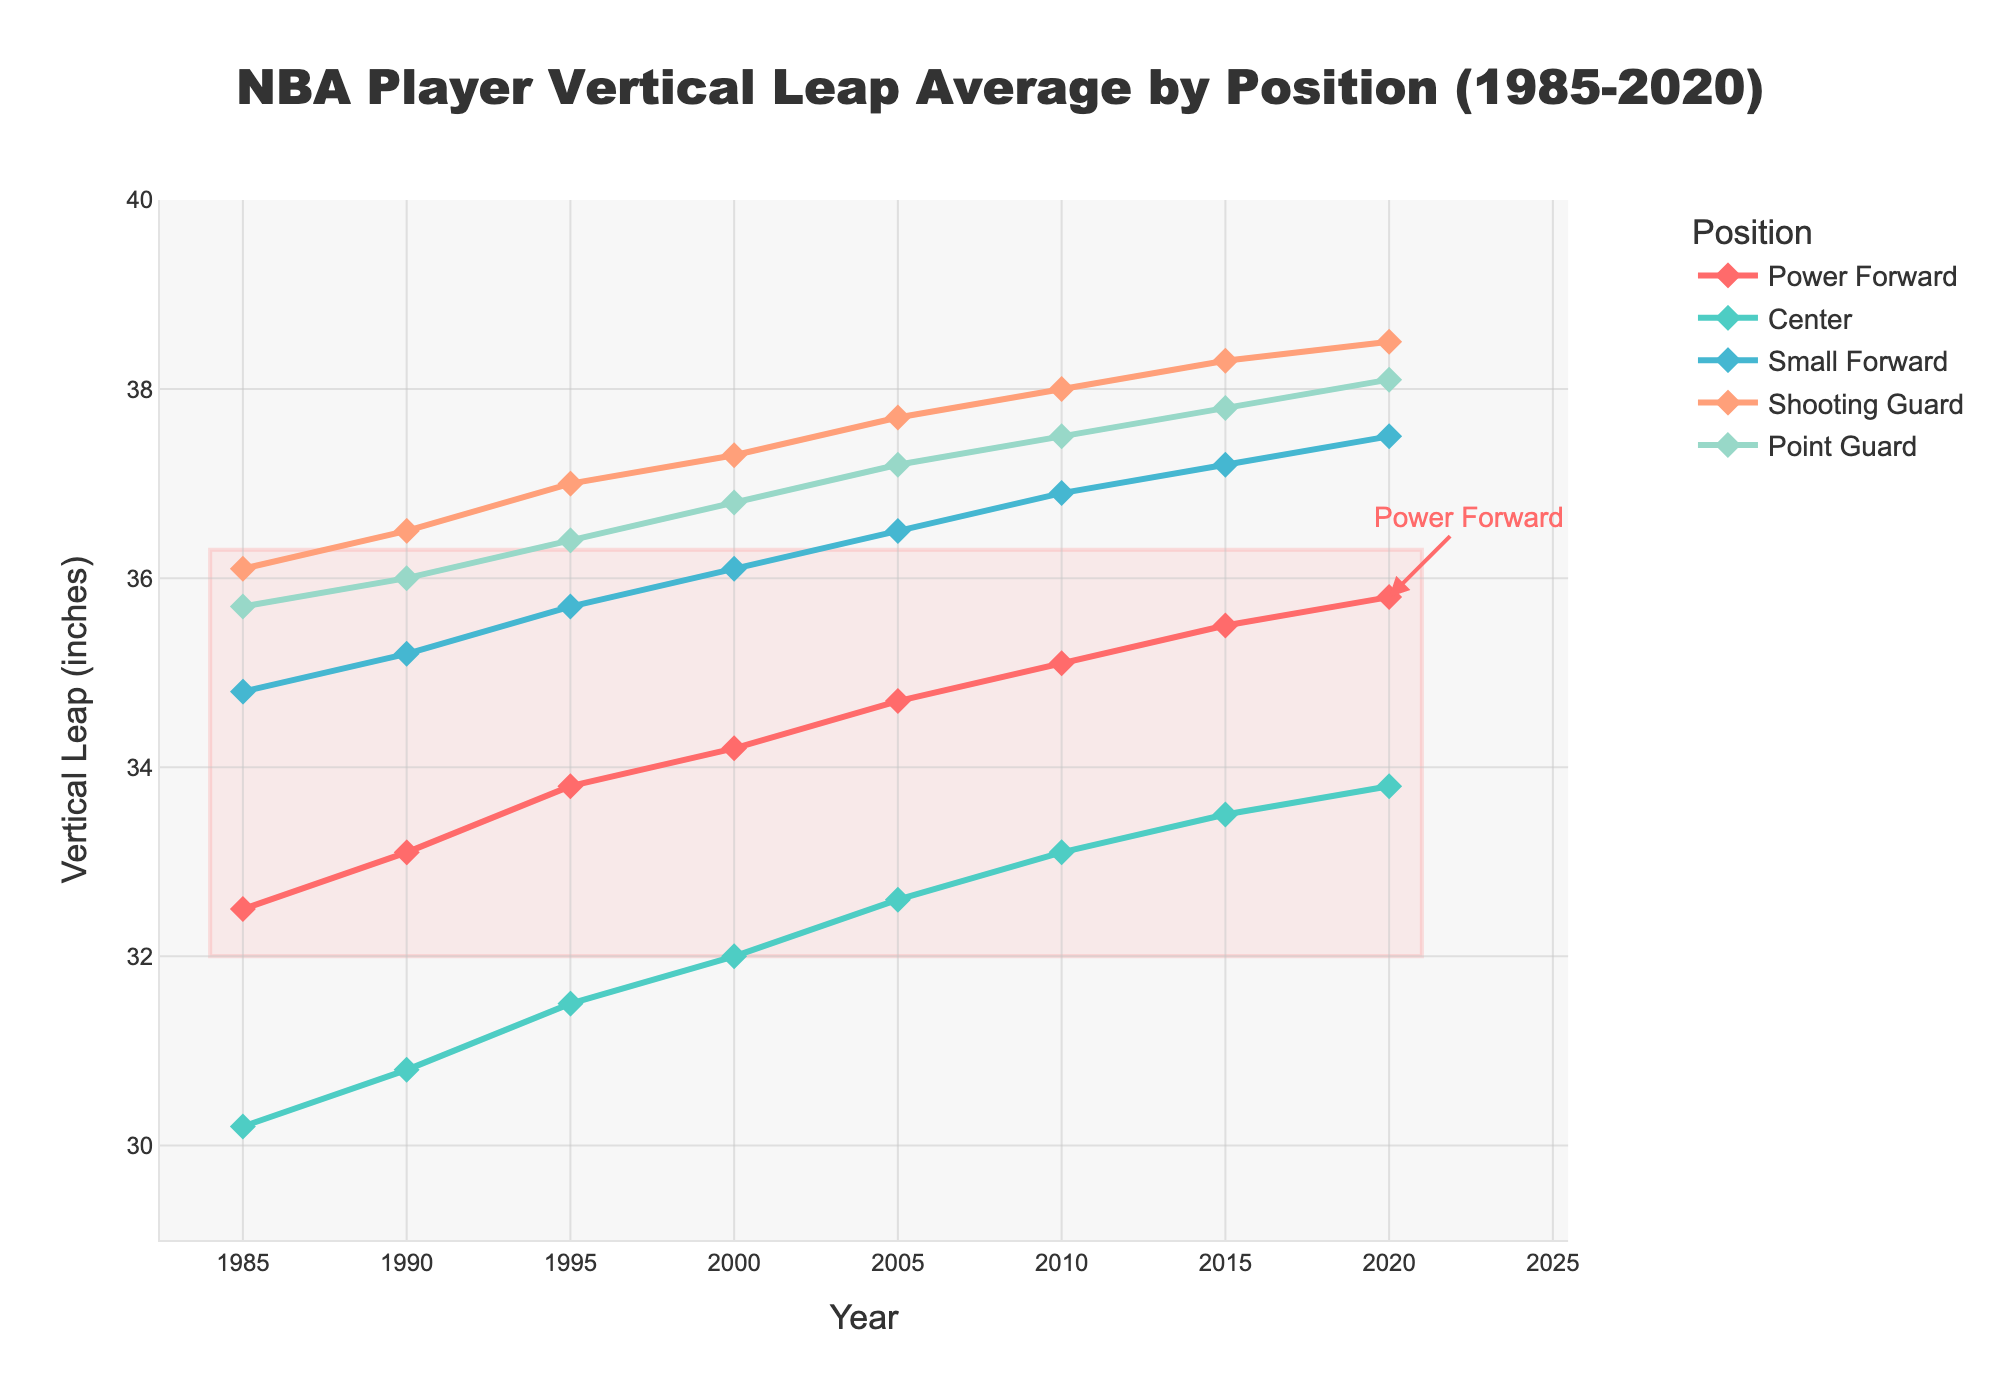What's the trend in vertical leap for Power Forwards from 1985 to 2020? The vertical leap for Power Forwards shows a gradual increase from 32.5 inches in 1985 to 35.8 inches in 2020. Each data point has a slightly higher value than the previous year, indicating an upward trend.
Answer: Gradual increase Which position had the highest vertical leap in 2010? By comparing the values for each position in 2010, the Shooting Guard had the highest vertical leap at 38.0 inches.
Answer: Shooting Guard How does the vertical leap of Centers in 2000 compare to that of Point Guards in 2000? In 2000, the vertical leap for Centers was 32.0 inches, while for Point Guards it was 36.8 inches. Comparing these, Point Guards had a significantly higher vertical leap than Centers.
Answer: Point Guards had a higher vertical leap What is the difference in vertical leap between Small Forwards and Power Forwards in 2020? The vertical leap for Small Forwards in 2020 was 37.5 inches and for Power Forwards it was 35.8 inches. The difference is 37.5 - 35.8 = 1.7 inches.
Answer: 1.7 inches Which two positions had the closest vertical leap values in 1995? In 1995, the values are: Power Forward (33.8), Center (31.5), Small Forward (35.7), Shooting Guard (37.0), and Point Guard (36.4). The closest values are for Shooting Guard (37.0) and Point Guard (36.4) with a difference of 0.6 inches.
Answer: Shooting Guard and Point Guard What is the average vertical leap for all positions in 2015? The vertical leaps for each position in 2015 are: Power Forward (35.5), Center (33.5), Small Forward (37.2), Shooting Guard (38.3), and Point Guard (37.8). The sum is 35.5 + 33.5 + 37.2 + 38.3 + 37.8 = 182.3. The average is 182.3 / 5 = 36.46 inches.
Answer: 36.46 inches Which position experienced the largest increase in vertical leap from 1985 to 2020? By calculating the increase for each position: Power Forward (3.3 inches), Center (3.6 inches), Small Forward (2.7 inches), Shooting Guard (2.4 inches), and Point Guard (2.4 inches). The Center position experienced the largest increase from 30.2 to 33.8 inches, a 3.6-inch increase.
Answer: Center How did the vertical leap of Shooting Guards compare to that of Small Forwards over the years? Over the entire time period, Shooting Guards consistently had a higher vertical leap than Small Forwards. For each specific year, the leap for Shooting Guards was higher by a small margin. The trend remains consistent from 1985 to 2020.
Answer: Shooting Guards consistently higher What position had the most stable vertical leap trend between 1985 and 2020? The trend for Centers shows the smallest change over time, with values increasing very steadily from 30.2 inches in 1985 to 33.8 inches in 2020 without any large jumps or drops. Other positions show more variance in their increases.
Answer: Center What is the combined vertical leap in 1990 for Power Forward and Shooting Guard? The vertical leap in 1990 for Power Forward is 33.1 inches and for Shooting Guard is 36.5 inches. The combined leap is 33.1 + 36.5 = 69.6 inches.
Answer: 69.6 inches 